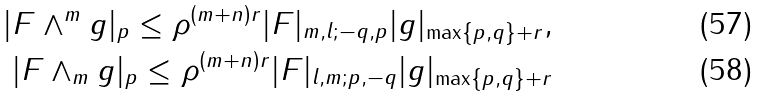<formula> <loc_0><loc_0><loc_500><loc_500>| F \wedge ^ { m } g | _ { p } \leq \rho ^ { ( m + n ) r } | F | _ { m , l ; - q , p } | g | _ { \max \{ p , q \} + r } , \\ | F \wedge _ { m } g | _ { p } \leq \rho ^ { ( m + n ) r } | F | _ { l , m ; p , - q } | g | _ { \max \{ p , q \} + r }</formula> 